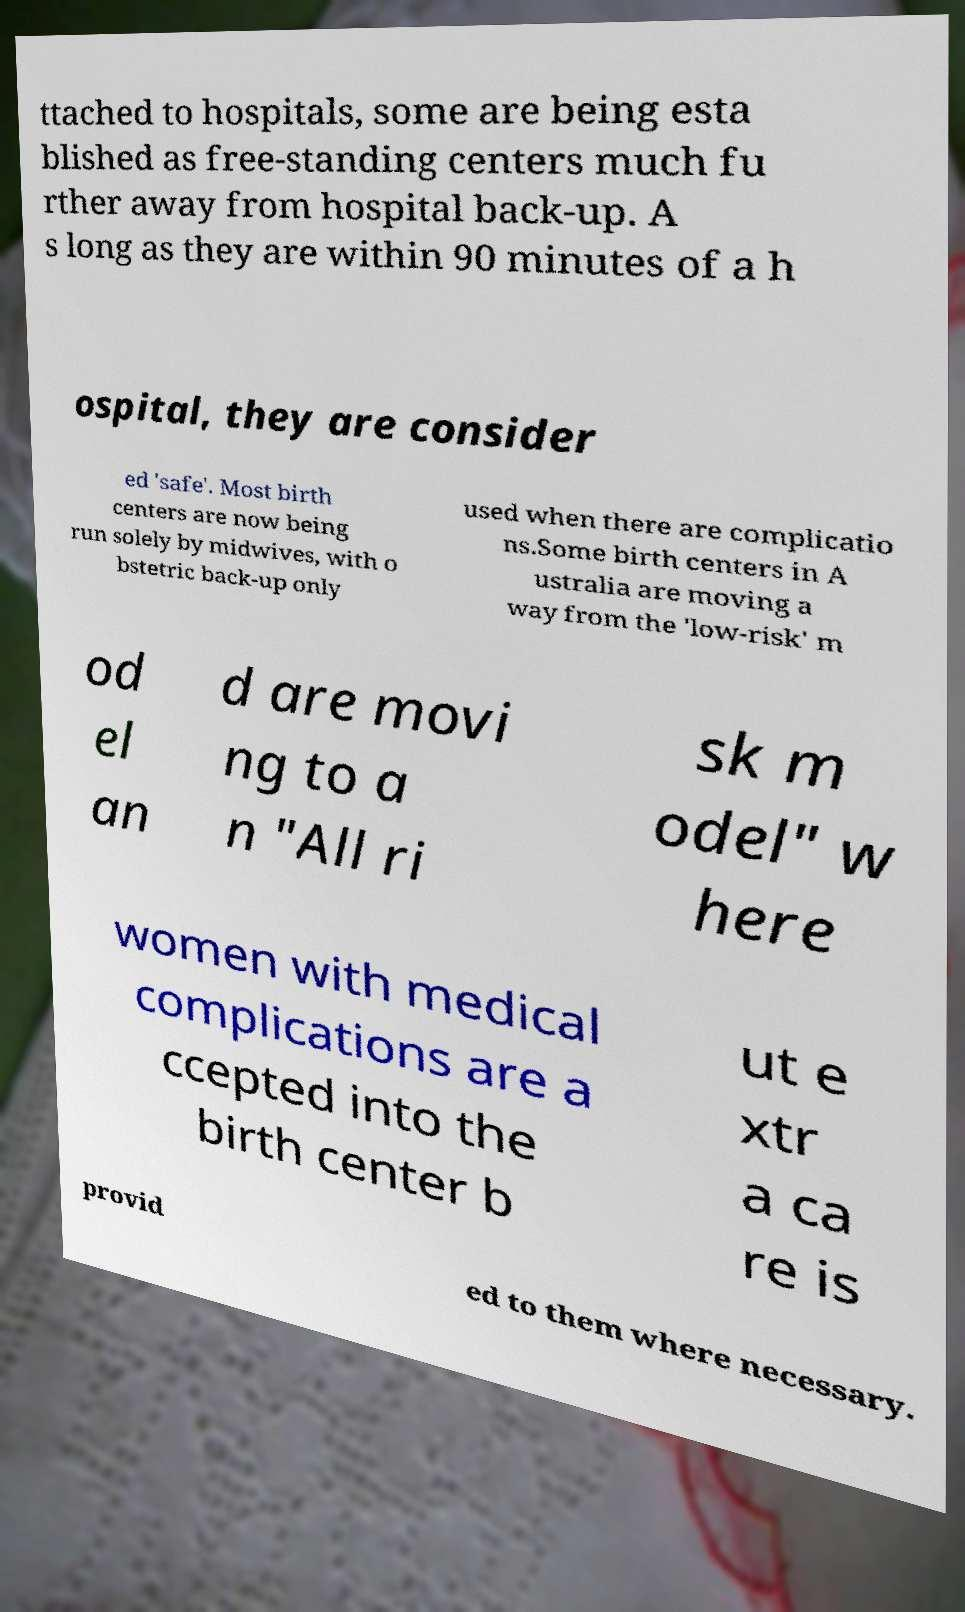Can you accurately transcribe the text from the provided image for me? ttached to hospitals, some are being esta blished as free-standing centers much fu rther away from hospital back-up. A s long as they are within 90 minutes of a h ospital, they are consider ed 'safe'. Most birth centers are now being run solely by midwives, with o bstetric back-up only used when there are complicatio ns.Some birth centers in A ustralia are moving a way from the 'low-risk' m od el an d are movi ng to a n "All ri sk m odel" w here women with medical complications are a ccepted into the birth center b ut e xtr a ca re is provid ed to them where necessary. 